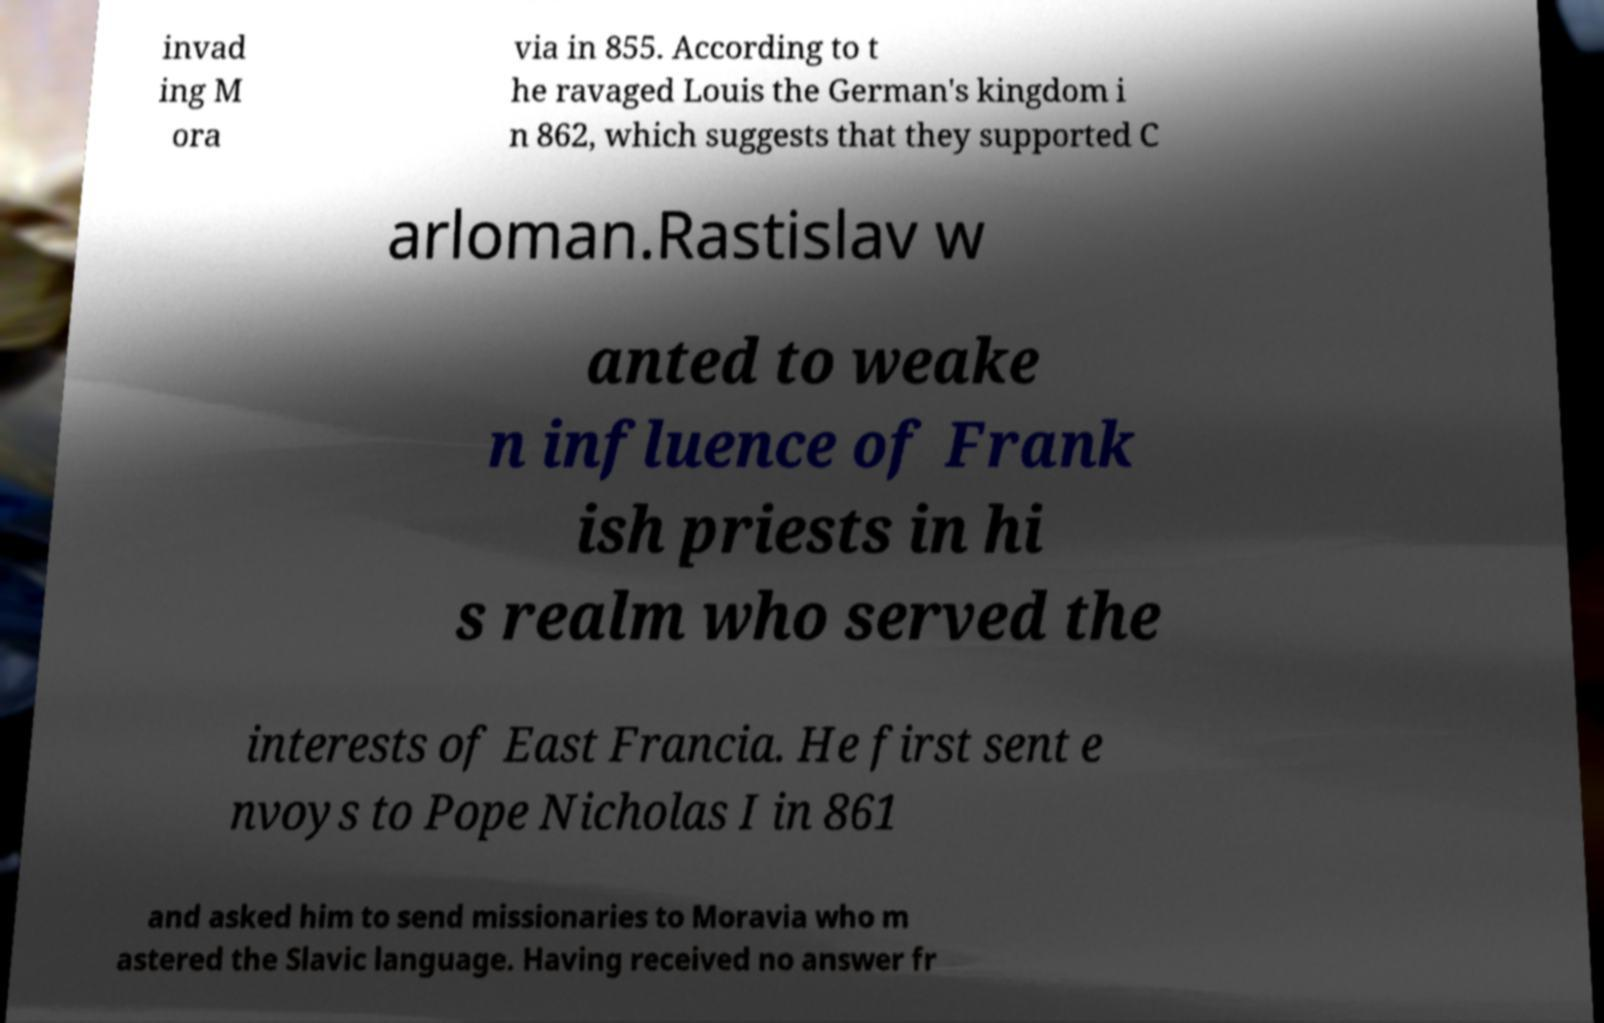Could you extract and type out the text from this image? invad ing M ora via in 855. According to t he ravaged Louis the German's kingdom i n 862, which suggests that they supported C arloman.Rastislav w anted to weake n influence of Frank ish priests in hi s realm who served the interests of East Francia. He first sent e nvoys to Pope Nicholas I in 861 and asked him to send missionaries to Moravia who m astered the Slavic language. Having received no answer fr 